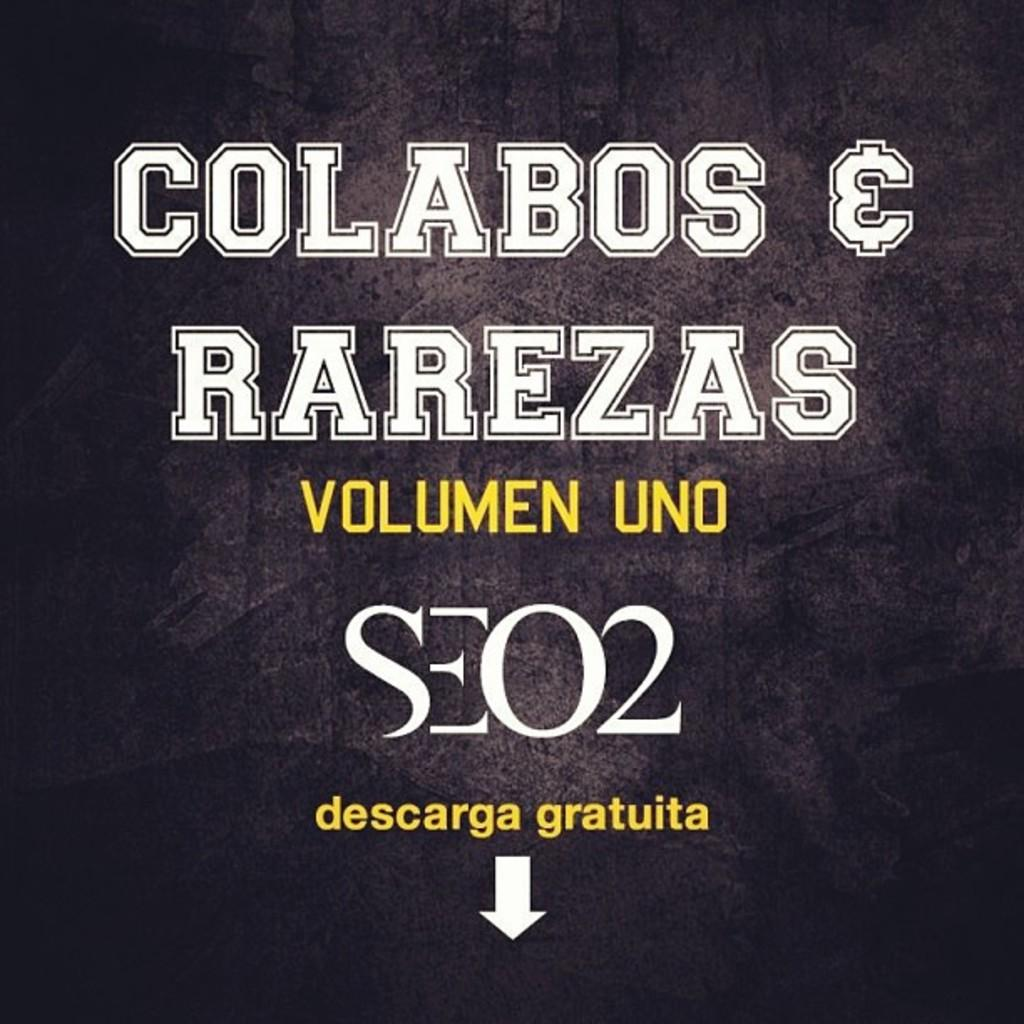<image>
Offer a succinct explanation of the picture presented. A black page with white text reading colabos & rarezas volume one. 